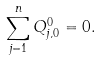<formula> <loc_0><loc_0><loc_500><loc_500>\sum _ { j = 1 } ^ { n } Q _ { j , 0 } ^ { 0 } = 0 .</formula> 